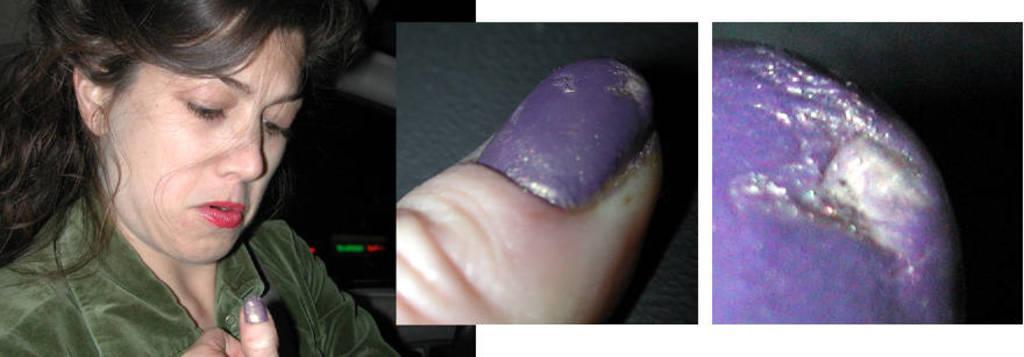Describe this image in one or two sentences. This is a collage picture. On the left side of the image there is a woman with green jacket. In the middle of the image there is a nail of a person and there is a purple color nail polish on the nail. At the bottom it looks like a floor. On the right side of the image there is a nail of a person. 